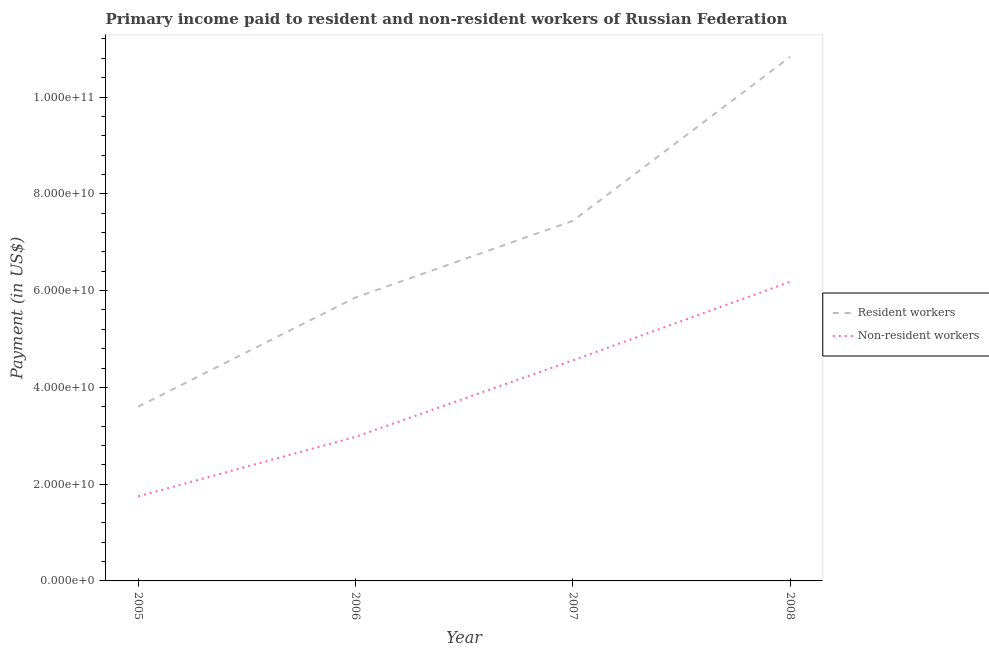How many different coloured lines are there?
Offer a very short reply. 2. What is the payment made to non-resident workers in 2007?
Ensure brevity in your answer.  4.56e+1. Across all years, what is the maximum payment made to non-resident workers?
Keep it short and to the point. 6.18e+1. Across all years, what is the minimum payment made to resident workers?
Ensure brevity in your answer.  3.60e+1. In which year was the payment made to non-resident workers minimum?
Make the answer very short. 2005. What is the total payment made to non-resident workers in the graph?
Offer a very short reply. 1.55e+11. What is the difference between the payment made to resident workers in 2006 and that in 2008?
Offer a terse response. -4.97e+1. What is the difference between the payment made to resident workers in 2007 and the payment made to non-resident workers in 2005?
Offer a terse response. 5.69e+1. What is the average payment made to non-resident workers per year?
Your response must be concise. 3.87e+1. In the year 2005, what is the difference between the payment made to resident workers and payment made to non-resident workers?
Your answer should be very brief. 1.85e+1. In how many years, is the payment made to non-resident workers greater than 24000000000 US$?
Keep it short and to the point. 3. What is the ratio of the payment made to non-resident workers in 2006 to that in 2007?
Your answer should be compact. 0.65. Is the payment made to resident workers in 2006 less than that in 2008?
Provide a succinct answer. Yes. Is the difference between the payment made to resident workers in 2006 and 2008 greater than the difference between the payment made to non-resident workers in 2006 and 2008?
Provide a short and direct response. No. What is the difference between the highest and the second highest payment made to non-resident workers?
Offer a terse response. 1.62e+1. What is the difference between the highest and the lowest payment made to non-resident workers?
Provide a short and direct response. 4.43e+1. In how many years, is the payment made to resident workers greater than the average payment made to resident workers taken over all years?
Offer a terse response. 2. Is the sum of the payment made to non-resident workers in 2005 and 2007 greater than the maximum payment made to resident workers across all years?
Your response must be concise. No. Is the payment made to non-resident workers strictly greater than the payment made to resident workers over the years?
Provide a succinct answer. No. How many years are there in the graph?
Your response must be concise. 4. Where does the legend appear in the graph?
Your answer should be compact. Center right. How many legend labels are there?
Your answer should be very brief. 2. How are the legend labels stacked?
Provide a succinct answer. Vertical. What is the title of the graph?
Offer a very short reply. Primary income paid to resident and non-resident workers of Russian Federation. What is the label or title of the Y-axis?
Your answer should be very brief. Payment (in US$). What is the Payment (in US$) in Resident workers in 2005?
Keep it short and to the point. 3.60e+1. What is the Payment (in US$) of Non-resident workers in 2005?
Your answer should be compact. 1.75e+1. What is the Payment (in US$) of Resident workers in 2006?
Your answer should be very brief. 5.86e+1. What is the Payment (in US$) of Non-resident workers in 2006?
Your answer should be compact. 2.98e+1. What is the Payment (in US$) in Resident workers in 2007?
Give a very brief answer. 7.44e+1. What is the Payment (in US$) in Non-resident workers in 2007?
Offer a terse response. 4.56e+1. What is the Payment (in US$) in Resident workers in 2008?
Keep it short and to the point. 1.08e+11. What is the Payment (in US$) in Non-resident workers in 2008?
Keep it short and to the point. 6.18e+1. Across all years, what is the maximum Payment (in US$) in Resident workers?
Your response must be concise. 1.08e+11. Across all years, what is the maximum Payment (in US$) in Non-resident workers?
Make the answer very short. 6.18e+1. Across all years, what is the minimum Payment (in US$) of Resident workers?
Ensure brevity in your answer.  3.60e+1. Across all years, what is the minimum Payment (in US$) in Non-resident workers?
Offer a terse response. 1.75e+1. What is the total Payment (in US$) in Resident workers in the graph?
Give a very brief answer. 2.77e+11. What is the total Payment (in US$) in Non-resident workers in the graph?
Offer a terse response. 1.55e+11. What is the difference between the Payment (in US$) of Resident workers in 2005 and that in 2006?
Your answer should be very brief. -2.26e+1. What is the difference between the Payment (in US$) in Non-resident workers in 2005 and that in 2006?
Provide a short and direct response. -1.23e+1. What is the difference between the Payment (in US$) in Resident workers in 2005 and that in 2007?
Offer a terse response. -3.84e+1. What is the difference between the Payment (in US$) in Non-resident workers in 2005 and that in 2007?
Your answer should be compact. -2.81e+1. What is the difference between the Payment (in US$) in Resident workers in 2005 and that in 2008?
Make the answer very short. -7.23e+1. What is the difference between the Payment (in US$) of Non-resident workers in 2005 and that in 2008?
Provide a succinct answer. -4.43e+1. What is the difference between the Payment (in US$) in Resident workers in 2006 and that in 2007?
Your answer should be very brief. -1.58e+1. What is the difference between the Payment (in US$) of Non-resident workers in 2006 and that in 2007?
Your response must be concise. -1.58e+1. What is the difference between the Payment (in US$) of Resident workers in 2006 and that in 2008?
Ensure brevity in your answer.  -4.97e+1. What is the difference between the Payment (in US$) of Non-resident workers in 2006 and that in 2008?
Your answer should be compact. -3.20e+1. What is the difference between the Payment (in US$) in Resident workers in 2007 and that in 2008?
Keep it short and to the point. -3.39e+1. What is the difference between the Payment (in US$) of Non-resident workers in 2007 and that in 2008?
Provide a succinct answer. -1.62e+1. What is the difference between the Payment (in US$) in Resident workers in 2005 and the Payment (in US$) in Non-resident workers in 2006?
Your response must be concise. 6.24e+09. What is the difference between the Payment (in US$) of Resident workers in 2005 and the Payment (in US$) of Non-resident workers in 2007?
Offer a very short reply. -9.58e+09. What is the difference between the Payment (in US$) of Resident workers in 2005 and the Payment (in US$) of Non-resident workers in 2008?
Give a very brief answer. -2.58e+1. What is the difference between the Payment (in US$) of Resident workers in 2006 and the Payment (in US$) of Non-resident workers in 2007?
Your response must be concise. 1.30e+1. What is the difference between the Payment (in US$) in Resident workers in 2006 and the Payment (in US$) in Non-resident workers in 2008?
Provide a succinct answer. -3.25e+09. What is the difference between the Payment (in US$) of Resident workers in 2007 and the Payment (in US$) of Non-resident workers in 2008?
Your answer should be very brief. 1.26e+1. What is the average Payment (in US$) of Resident workers per year?
Provide a succinct answer. 6.93e+1. What is the average Payment (in US$) in Non-resident workers per year?
Give a very brief answer. 3.87e+1. In the year 2005, what is the difference between the Payment (in US$) in Resident workers and Payment (in US$) in Non-resident workers?
Keep it short and to the point. 1.85e+1. In the year 2006, what is the difference between the Payment (in US$) of Resident workers and Payment (in US$) of Non-resident workers?
Provide a short and direct response. 2.88e+1. In the year 2007, what is the difference between the Payment (in US$) in Resident workers and Payment (in US$) in Non-resident workers?
Offer a very short reply. 2.88e+1. In the year 2008, what is the difference between the Payment (in US$) in Resident workers and Payment (in US$) in Non-resident workers?
Offer a very short reply. 4.65e+1. What is the ratio of the Payment (in US$) in Resident workers in 2005 to that in 2006?
Provide a short and direct response. 0.61. What is the ratio of the Payment (in US$) of Non-resident workers in 2005 to that in 2006?
Ensure brevity in your answer.  0.59. What is the ratio of the Payment (in US$) of Resident workers in 2005 to that in 2007?
Keep it short and to the point. 0.48. What is the ratio of the Payment (in US$) of Non-resident workers in 2005 to that in 2007?
Your answer should be compact. 0.38. What is the ratio of the Payment (in US$) of Resident workers in 2005 to that in 2008?
Make the answer very short. 0.33. What is the ratio of the Payment (in US$) in Non-resident workers in 2005 to that in 2008?
Your answer should be compact. 0.28. What is the ratio of the Payment (in US$) of Resident workers in 2006 to that in 2007?
Your answer should be very brief. 0.79. What is the ratio of the Payment (in US$) of Non-resident workers in 2006 to that in 2007?
Offer a very short reply. 0.65. What is the ratio of the Payment (in US$) of Resident workers in 2006 to that in 2008?
Your response must be concise. 0.54. What is the ratio of the Payment (in US$) in Non-resident workers in 2006 to that in 2008?
Make the answer very short. 0.48. What is the ratio of the Payment (in US$) of Resident workers in 2007 to that in 2008?
Give a very brief answer. 0.69. What is the ratio of the Payment (in US$) of Non-resident workers in 2007 to that in 2008?
Your response must be concise. 0.74. What is the difference between the highest and the second highest Payment (in US$) of Resident workers?
Offer a very short reply. 3.39e+1. What is the difference between the highest and the second highest Payment (in US$) of Non-resident workers?
Offer a very short reply. 1.62e+1. What is the difference between the highest and the lowest Payment (in US$) in Resident workers?
Give a very brief answer. 7.23e+1. What is the difference between the highest and the lowest Payment (in US$) in Non-resident workers?
Your response must be concise. 4.43e+1. 